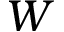<formula> <loc_0><loc_0><loc_500><loc_500>W</formula> 